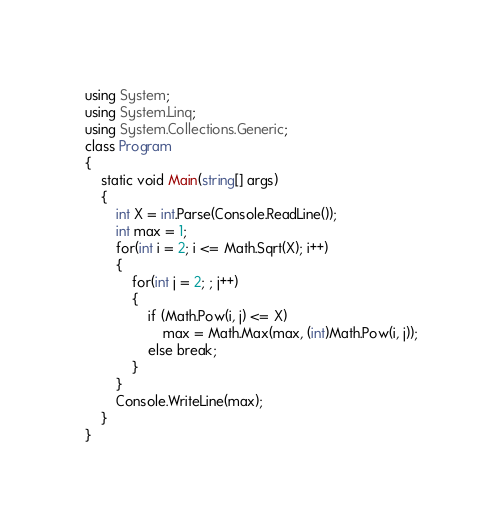<code> <loc_0><loc_0><loc_500><loc_500><_C#_>using System;
using System.Linq;
using System.Collections.Generic;
class Program
{
    static void Main(string[] args)
    {
        int X = int.Parse(Console.ReadLine());
        int max = 1;
        for(int i = 2; i <= Math.Sqrt(X); i++)
        {
            for(int j = 2; ; j++)
            {
                if (Math.Pow(i, j) <= X)
                    max = Math.Max(max, (int)Math.Pow(i, j));
                else break;
            }
        }
        Console.WriteLine(max);
    }
}
</code> 